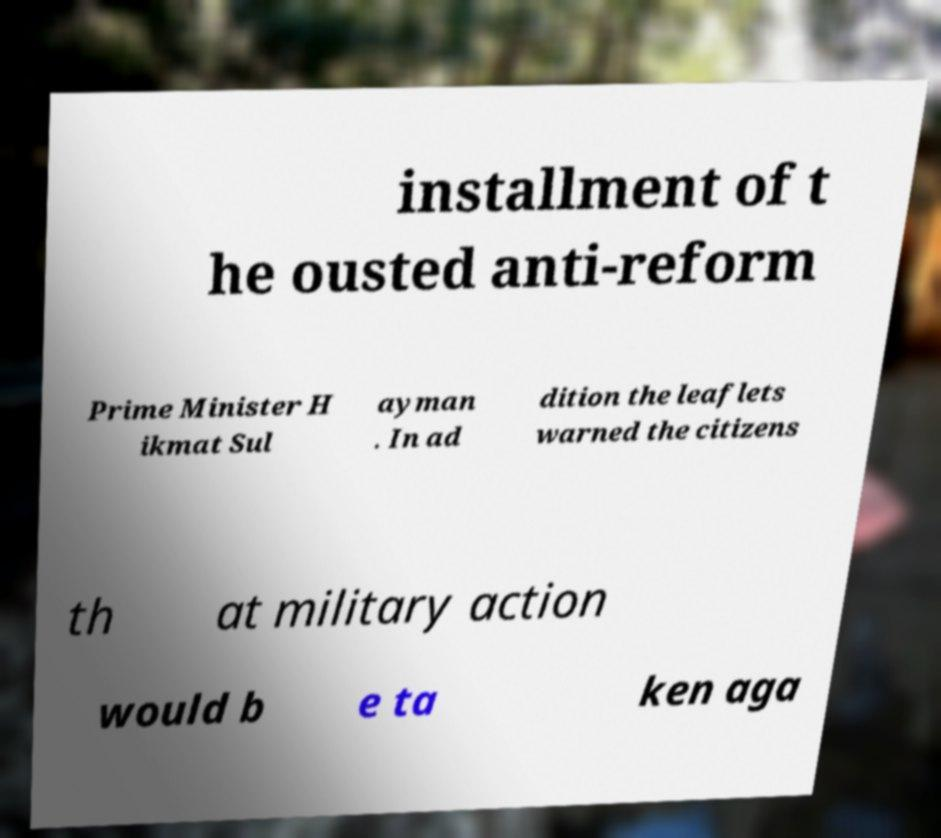Please read and relay the text visible in this image. What does it say? installment of t he ousted anti-reform Prime Minister H ikmat Sul ayman . In ad dition the leaflets warned the citizens th at military action would b e ta ken aga 